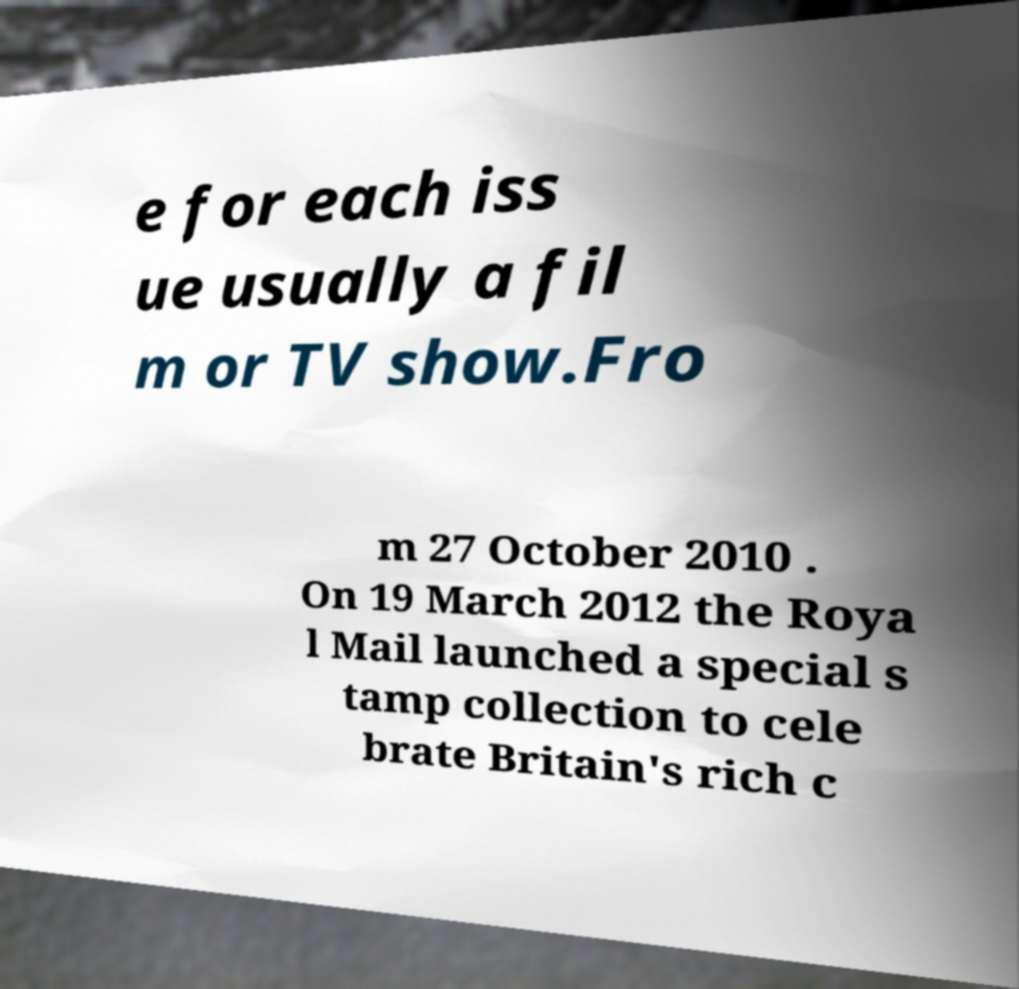Can you accurately transcribe the text from the provided image for me? e for each iss ue usually a fil m or TV show.Fro m 27 October 2010 . On 19 March 2012 the Roya l Mail launched a special s tamp collection to cele brate Britain's rich c 